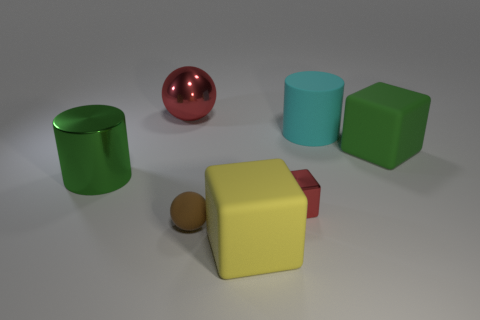Subtract all green matte blocks. How many blocks are left? 2 Subtract all blocks. How many objects are left? 4 Subtract all green cubes. How many cubes are left? 2 Add 1 yellow matte cylinders. How many objects exist? 8 Subtract 2 spheres. How many spheres are left? 0 Subtract all gray blocks. How many green balls are left? 0 Subtract all cyan objects. Subtract all metallic objects. How many objects are left? 3 Add 5 brown matte balls. How many brown matte balls are left? 6 Add 2 yellow objects. How many yellow objects exist? 3 Subtract 1 green cylinders. How many objects are left? 6 